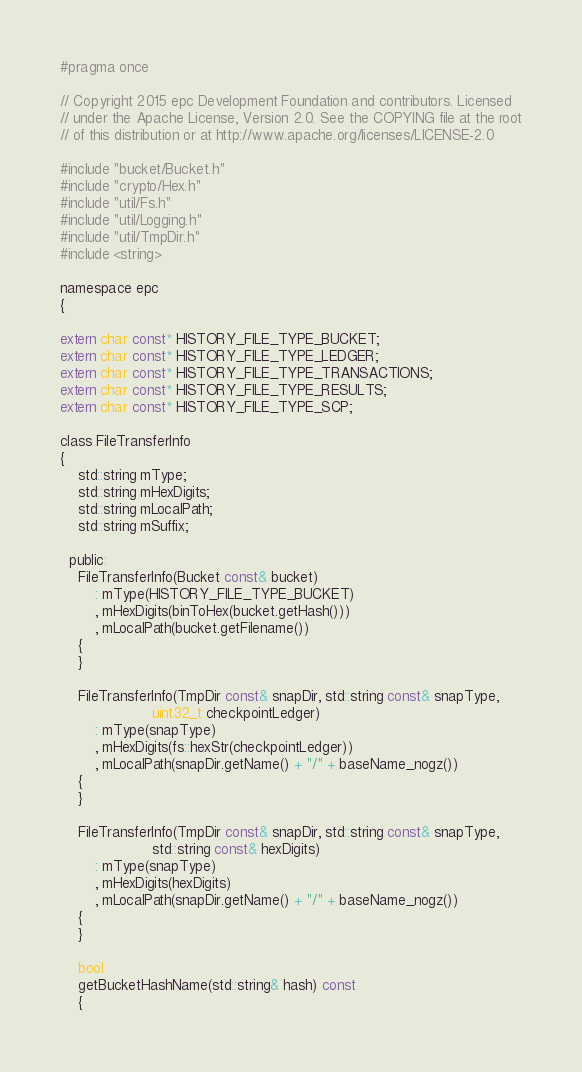<code> <loc_0><loc_0><loc_500><loc_500><_C_>#pragma once

// Copyright 2015 epc Development Foundation and contributors. Licensed
// under the Apache License, Version 2.0. See the COPYING file at the root
// of this distribution or at http://www.apache.org/licenses/LICENSE-2.0

#include "bucket/Bucket.h"
#include "crypto/Hex.h"
#include "util/Fs.h"
#include "util/Logging.h"
#include "util/TmpDir.h"
#include <string>

namespace epc
{

extern char const* HISTORY_FILE_TYPE_BUCKET;
extern char const* HISTORY_FILE_TYPE_LEDGER;
extern char const* HISTORY_FILE_TYPE_TRANSACTIONS;
extern char const* HISTORY_FILE_TYPE_RESULTS;
extern char const* HISTORY_FILE_TYPE_SCP;

class FileTransferInfo
{
    std::string mType;
    std::string mHexDigits;
    std::string mLocalPath;
    std::string mSuffix;

  public:
    FileTransferInfo(Bucket const& bucket)
        : mType(HISTORY_FILE_TYPE_BUCKET)
        , mHexDigits(binToHex(bucket.getHash()))
        , mLocalPath(bucket.getFilename())
    {
    }

    FileTransferInfo(TmpDir const& snapDir, std::string const& snapType,
                     uint32_t checkpointLedger)
        : mType(snapType)
        , mHexDigits(fs::hexStr(checkpointLedger))
        , mLocalPath(snapDir.getName() + "/" + baseName_nogz())
    {
    }

    FileTransferInfo(TmpDir const& snapDir, std::string const& snapType,
                     std::string const& hexDigits)
        : mType(snapType)
        , mHexDigits(hexDigits)
        , mLocalPath(snapDir.getName() + "/" + baseName_nogz())
    {
    }

    bool
    getBucketHashName(std::string& hash) const
    {</code> 